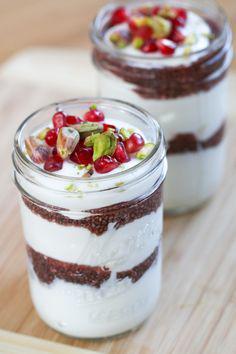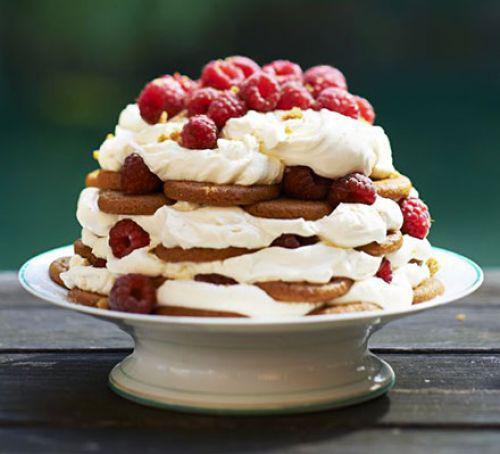The first image is the image on the left, the second image is the image on the right. Given the left and right images, does the statement "The image on the left shows a single bowl of trifle while the image on the right shows two pedestal bowls of trifle." hold true? Answer yes or no. No. 